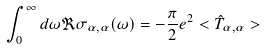<formula> <loc_0><loc_0><loc_500><loc_500>\int _ { 0 } ^ { \infty } d \omega \Re \sigma _ { \alpha , \alpha } ( \omega ) = - \frac { \pi } { 2 } e ^ { 2 } < \hat { T } _ { \alpha , \alpha } ></formula> 